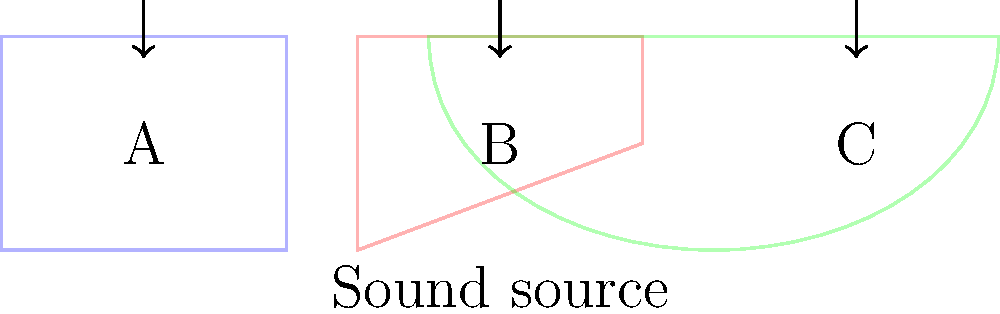As a movie critic evaluating cinema acoustics, you're analyzing sound wave propagation in different theater layouts. The diagram shows three common designs: rectangular (A), fan-shaped (B), and curved (C). Which layout is likely to provide the most uniform sound distribution throughout the audience, and why? To answer this question, we need to consider how sound waves propagate in each theater layout:

1. Rectangular (A):
   - Sound waves reflect off parallel walls, creating standing waves.
   - This can lead to uneven sound distribution with "dead spots" and "hot spots."
   - Formula for standing waves: $f = \frac{n v}{2L}$, where $f$ is frequency, $n$ is mode, $v$ is wave velocity, and $L$ is room dimension.

2. Fan-shaped (B):
   - Angled walls reduce parallel reflections, improving sound distribution.
   - However, the rear of the theater may receive less sound energy.
   - Sound intensity decreases according to the inverse square law: $I \propto \frac{1}{r^2}$, where $I$ is intensity and $r$ is distance from the source.

3. Curved (C):
   - The curved shape helps to focus sound waves towards the audience.
   - It minimizes parallel reflections and reduces standing waves.
   - The curvature follows the principle of a parabolic reflector, which can be described by the equation $y = ax^2$, where $a$ is the focal parameter.

The curved layout (C) is likely to provide the most uniform sound distribution because:
- It minimizes parallel reflections that cause standing waves.
- The curved shape helps to focus sound energy towards the audience more evenly.
- It reduces the formation of dead spots and hot spots.
- The parabolic shape can be optimized to direct sound waves efficiently to all areas of the audience.

This design is often used in concert halls and high-end movie theaters to achieve superior acoustics.
Answer: Curved layout (C) 